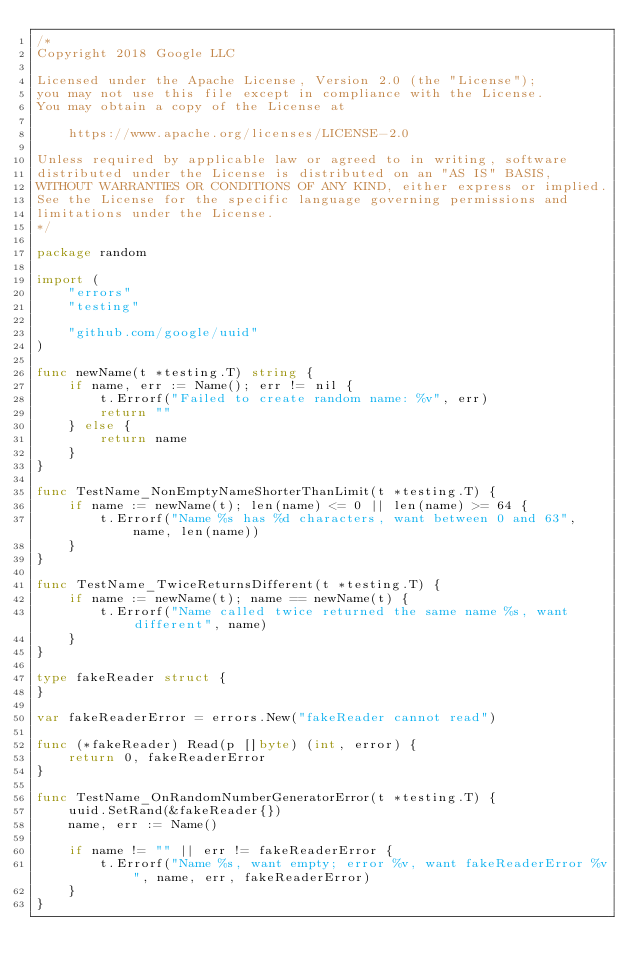<code> <loc_0><loc_0><loc_500><loc_500><_Go_>/*
Copyright 2018 Google LLC

Licensed under the Apache License, Version 2.0 (the "License");
you may not use this file except in compliance with the License.
You may obtain a copy of the License at

    https://www.apache.org/licenses/LICENSE-2.0

Unless required by applicable law or agreed to in writing, software
distributed under the License is distributed on an "AS IS" BASIS,
WITHOUT WARRANTIES OR CONDITIONS OF ANY KIND, either express or implied.
See the License for the specific language governing permissions and
limitations under the License.
*/

package random

import (
	"errors"
	"testing"

	"github.com/google/uuid"
)

func newName(t *testing.T) string {
	if name, err := Name(); err != nil {
		t.Errorf("Failed to create random name: %v", err)
		return ""
	} else {
		return name
	}
}

func TestName_NonEmptyNameShorterThanLimit(t *testing.T) {
	if name := newName(t); len(name) <= 0 || len(name) >= 64 {
		t.Errorf("Name %s has %d characters, want between 0 and 63", name, len(name))
	}
}

func TestName_TwiceReturnsDifferent(t *testing.T) {
	if name := newName(t); name == newName(t) {
		t.Errorf("Name called twice returned the same name %s, want different", name)
	}
}

type fakeReader struct {
}

var fakeReaderError = errors.New("fakeReader cannot read")

func (*fakeReader) Read(p []byte) (int, error) {
	return 0, fakeReaderError
}

func TestName_OnRandomNumberGeneratorError(t *testing.T) {
	uuid.SetRand(&fakeReader{})
	name, err := Name()

	if name != "" || err != fakeReaderError {
		t.Errorf("Name %s, want empty; error %v, want fakeReaderError %v", name, err, fakeReaderError)
	}
}
</code> 